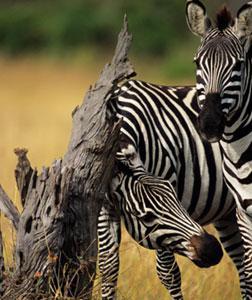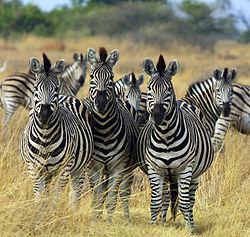The first image is the image on the left, the second image is the image on the right. Given the left and right images, does the statement "In exactly one of the images there is at least one zebra with its front legs off the ground." hold true? Answer yes or no. No. The first image is the image on the left, the second image is the image on the right. Assess this claim about the two images: "Both images show zebras fighting, though one has only two zebras and the other image has more.". Correct or not? Answer yes or no. No. 